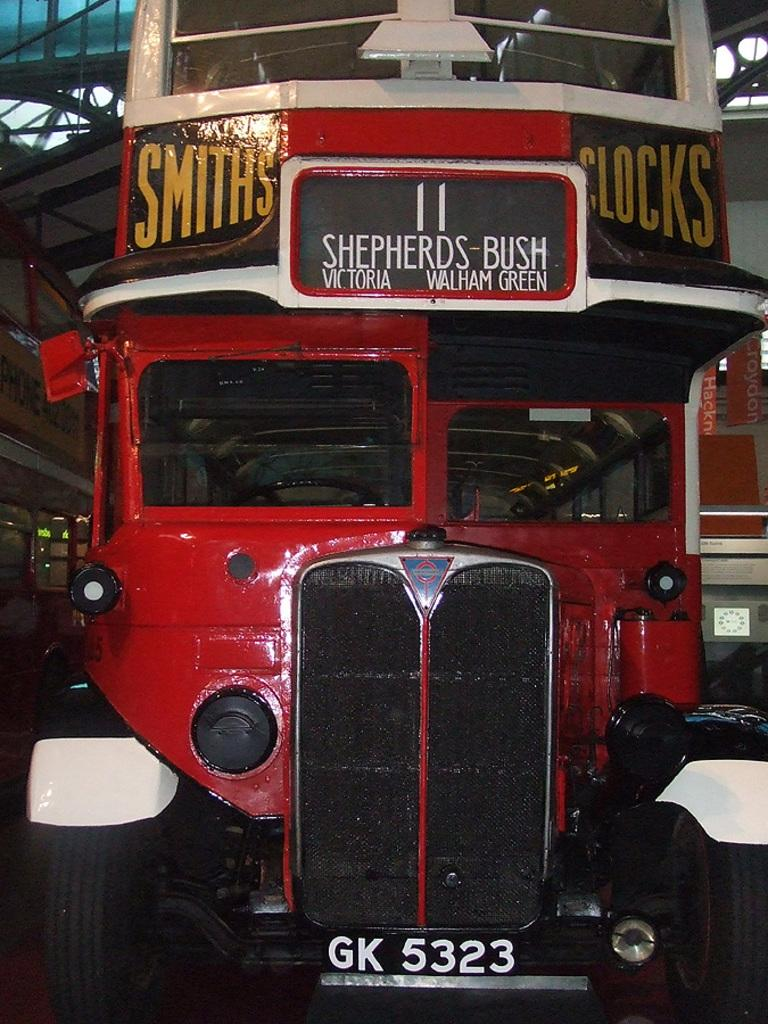What can be seen in the image? There are vehicles in the image. What is visible in the background of the image? There is a roof, a wall, and boards visible in the background of the image. How many frogs are sitting on the vehicles in the image? There are no frogs present in the image. What grade is the wall in the image? The wall in the image is not associated with a grade; it is simply a wall. 